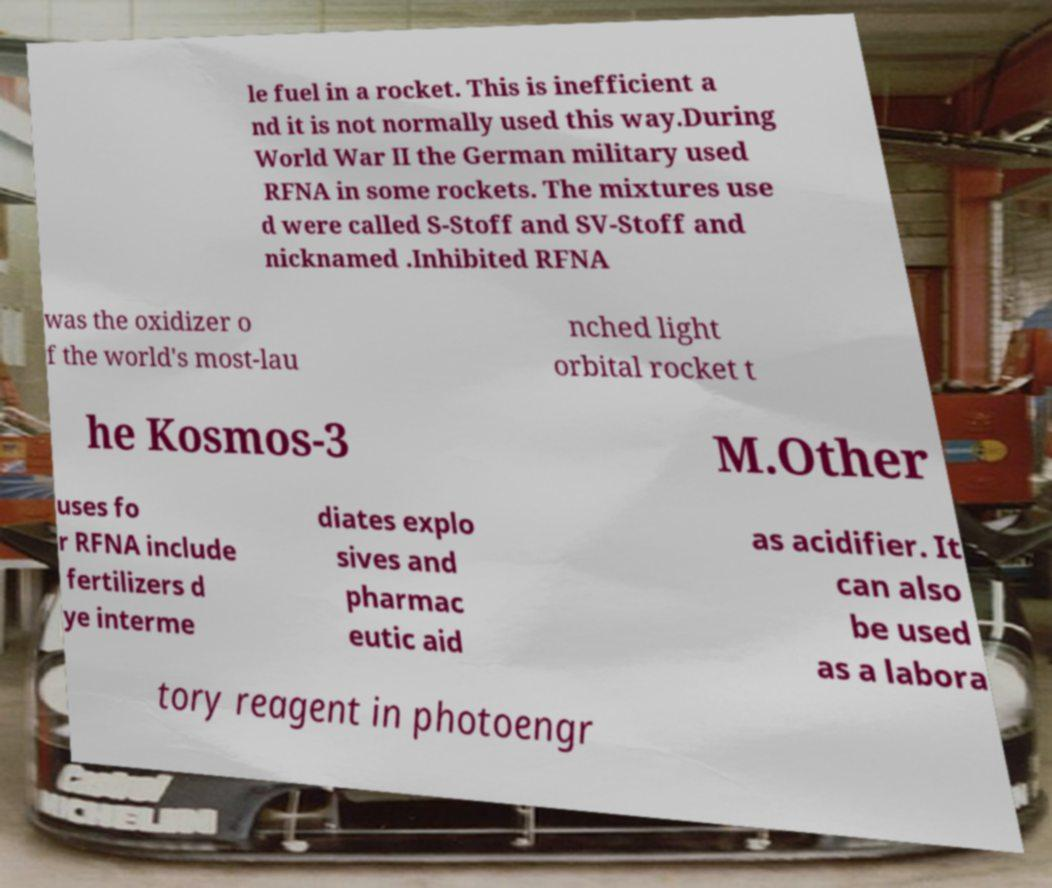For documentation purposes, I need the text within this image transcribed. Could you provide that? le fuel in a rocket. This is inefficient a nd it is not normally used this way.During World War II the German military used RFNA in some rockets. The mixtures use d were called S-Stoff and SV-Stoff and nicknamed .Inhibited RFNA was the oxidizer o f the world's most-lau nched light orbital rocket t he Kosmos-3 M.Other uses fo r RFNA include fertilizers d ye interme diates explo sives and pharmac eutic aid as acidifier. It can also be used as a labora tory reagent in photoengr 